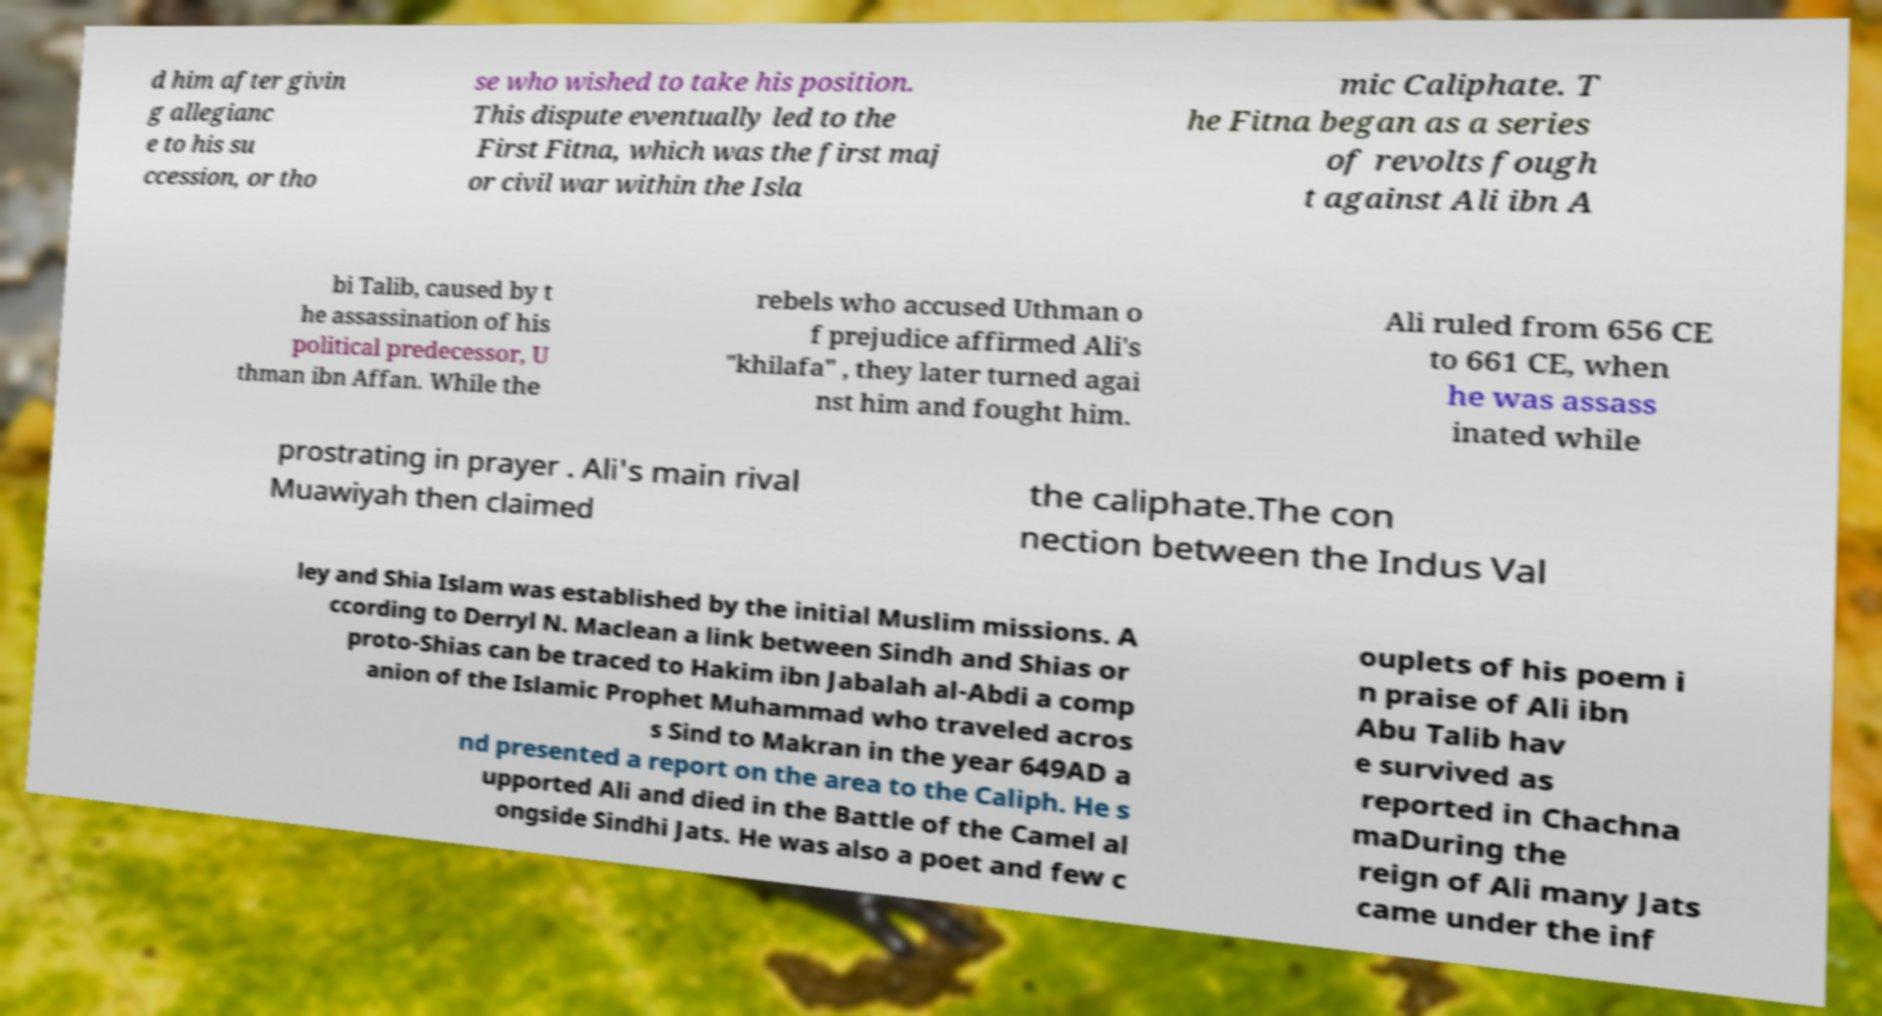Can you read and provide the text displayed in the image?This photo seems to have some interesting text. Can you extract and type it out for me? d him after givin g allegianc e to his su ccession, or tho se who wished to take his position. This dispute eventually led to the First Fitna, which was the first maj or civil war within the Isla mic Caliphate. T he Fitna began as a series of revolts fough t against Ali ibn A bi Talib, caused by t he assassination of his political predecessor, U thman ibn Affan. While the rebels who accused Uthman o f prejudice affirmed Ali's "khilafa" , they later turned agai nst him and fought him. Ali ruled from 656 CE to 661 CE, when he was assass inated while prostrating in prayer . Ali's main rival Muawiyah then claimed the caliphate.The con nection between the Indus Val ley and Shia Islam was established by the initial Muslim missions. A ccording to Derryl N. Maclean a link between Sindh and Shias or proto-Shias can be traced to Hakim ibn Jabalah al-Abdi a comp anion of the Islamic Prophet Muhammad who traveled acros s Sind to Makran in the year 649AD a nd presented a report on the area to the Caliph. He s upported Ali and died in the Battle of the Camel al ongside Sindhi Jats. He was also a poet and few c ouplets of his poem i n praise of Ali ibn Abu Talib hav e survived as reported in Chachna maDuring the reign of Ali many Jats came under the inf 